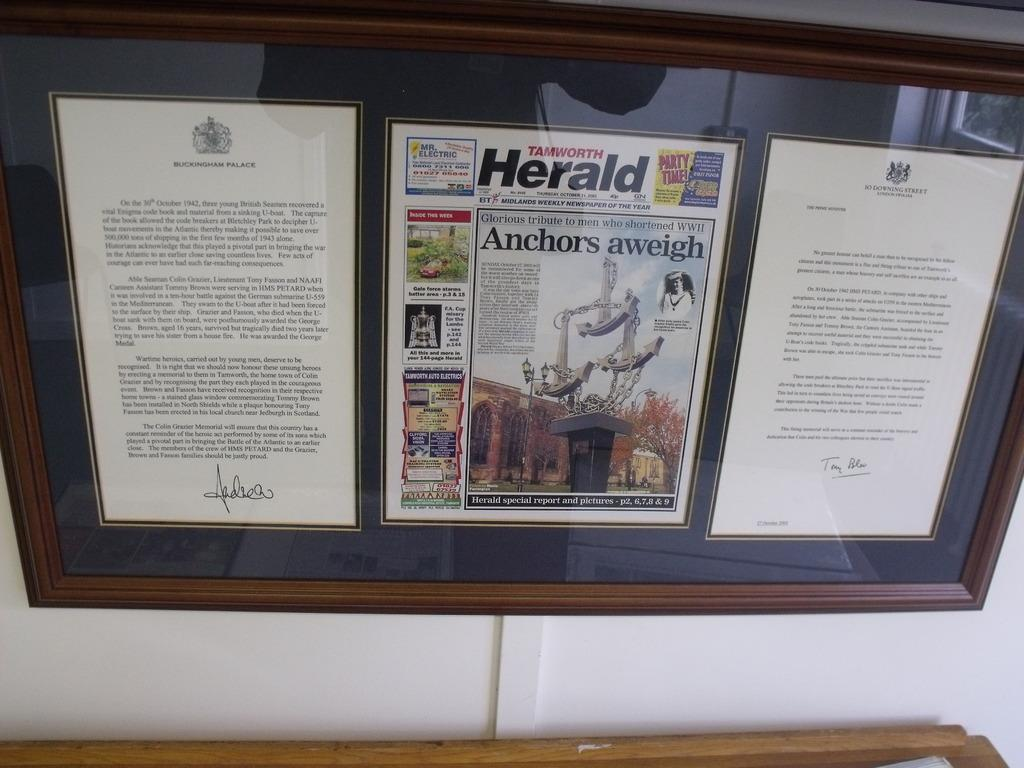Provide a one-sentence caption for the provided image. A glass display containing a copy of the Tamworth Herald. 